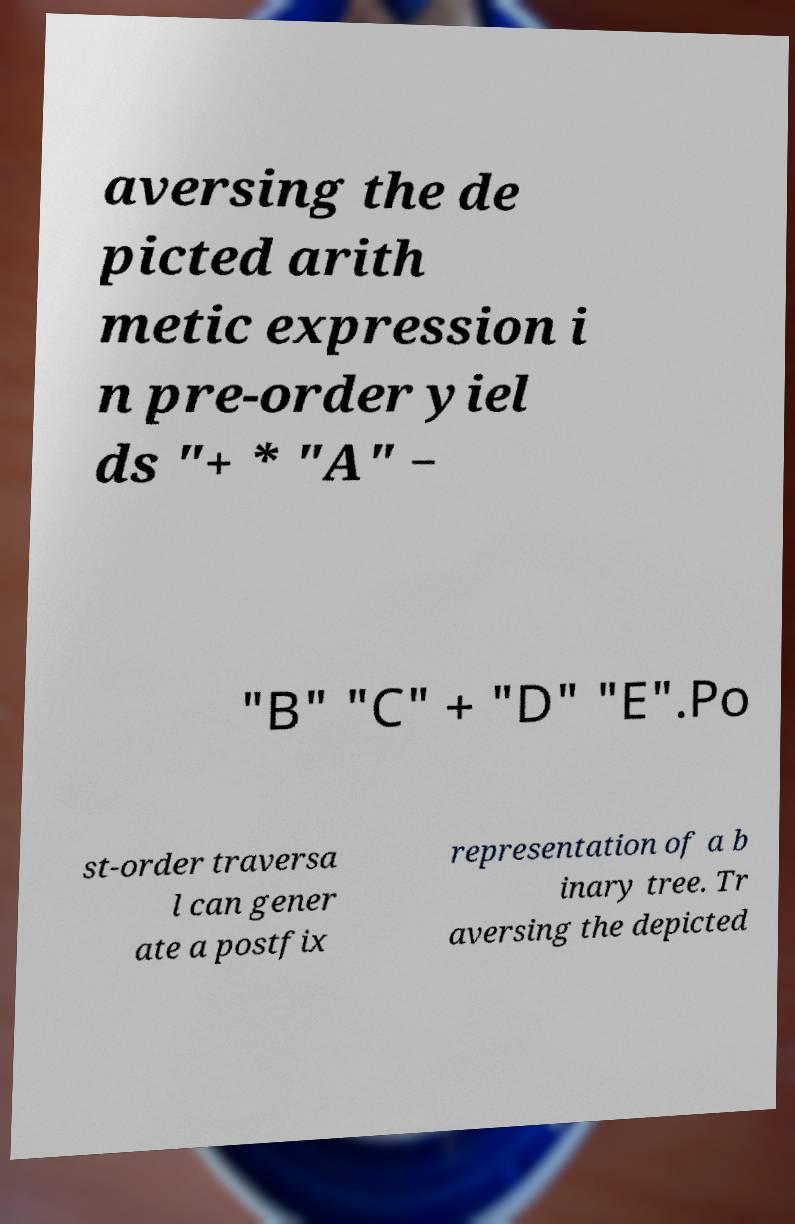There's text embedded in this image that I need extracted. Can you transcribe it verbatim? aversing the de picted arith metic expression i n pre-order yiel ds "+ * "A" − "B" "C" + "D" "E".Po st-order traversa l can gener ate a postfix representation of a b inary tree. Tr aversing the depicted 